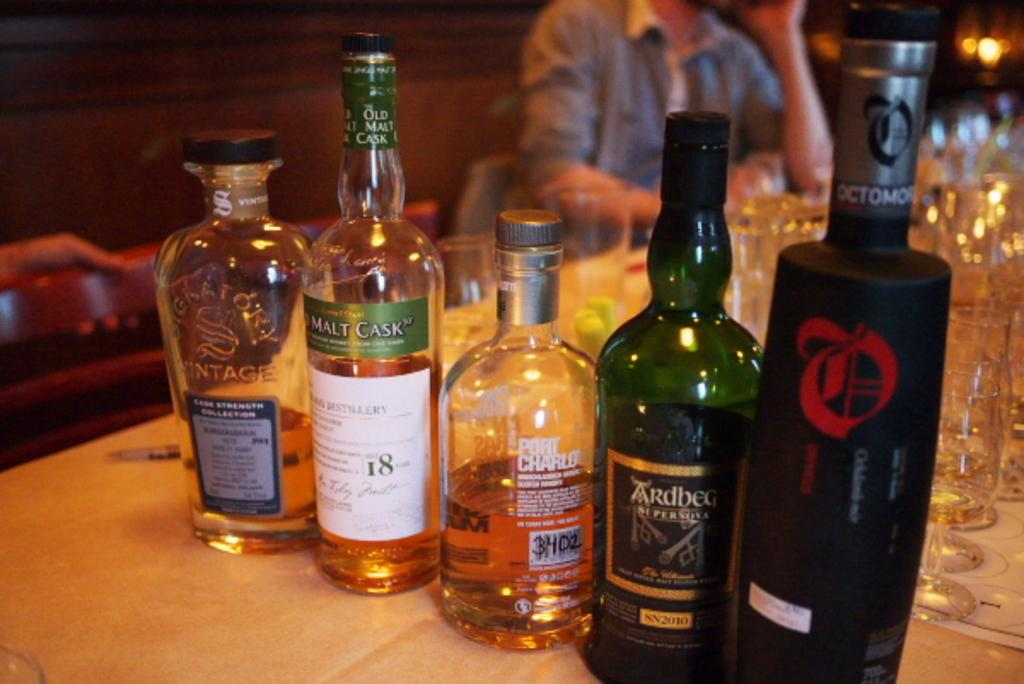Provide a one-sentence caption for the provided image. A row of bottles are lined up on a counter including a green bottle with a label that reads, "Ardbeg.". 